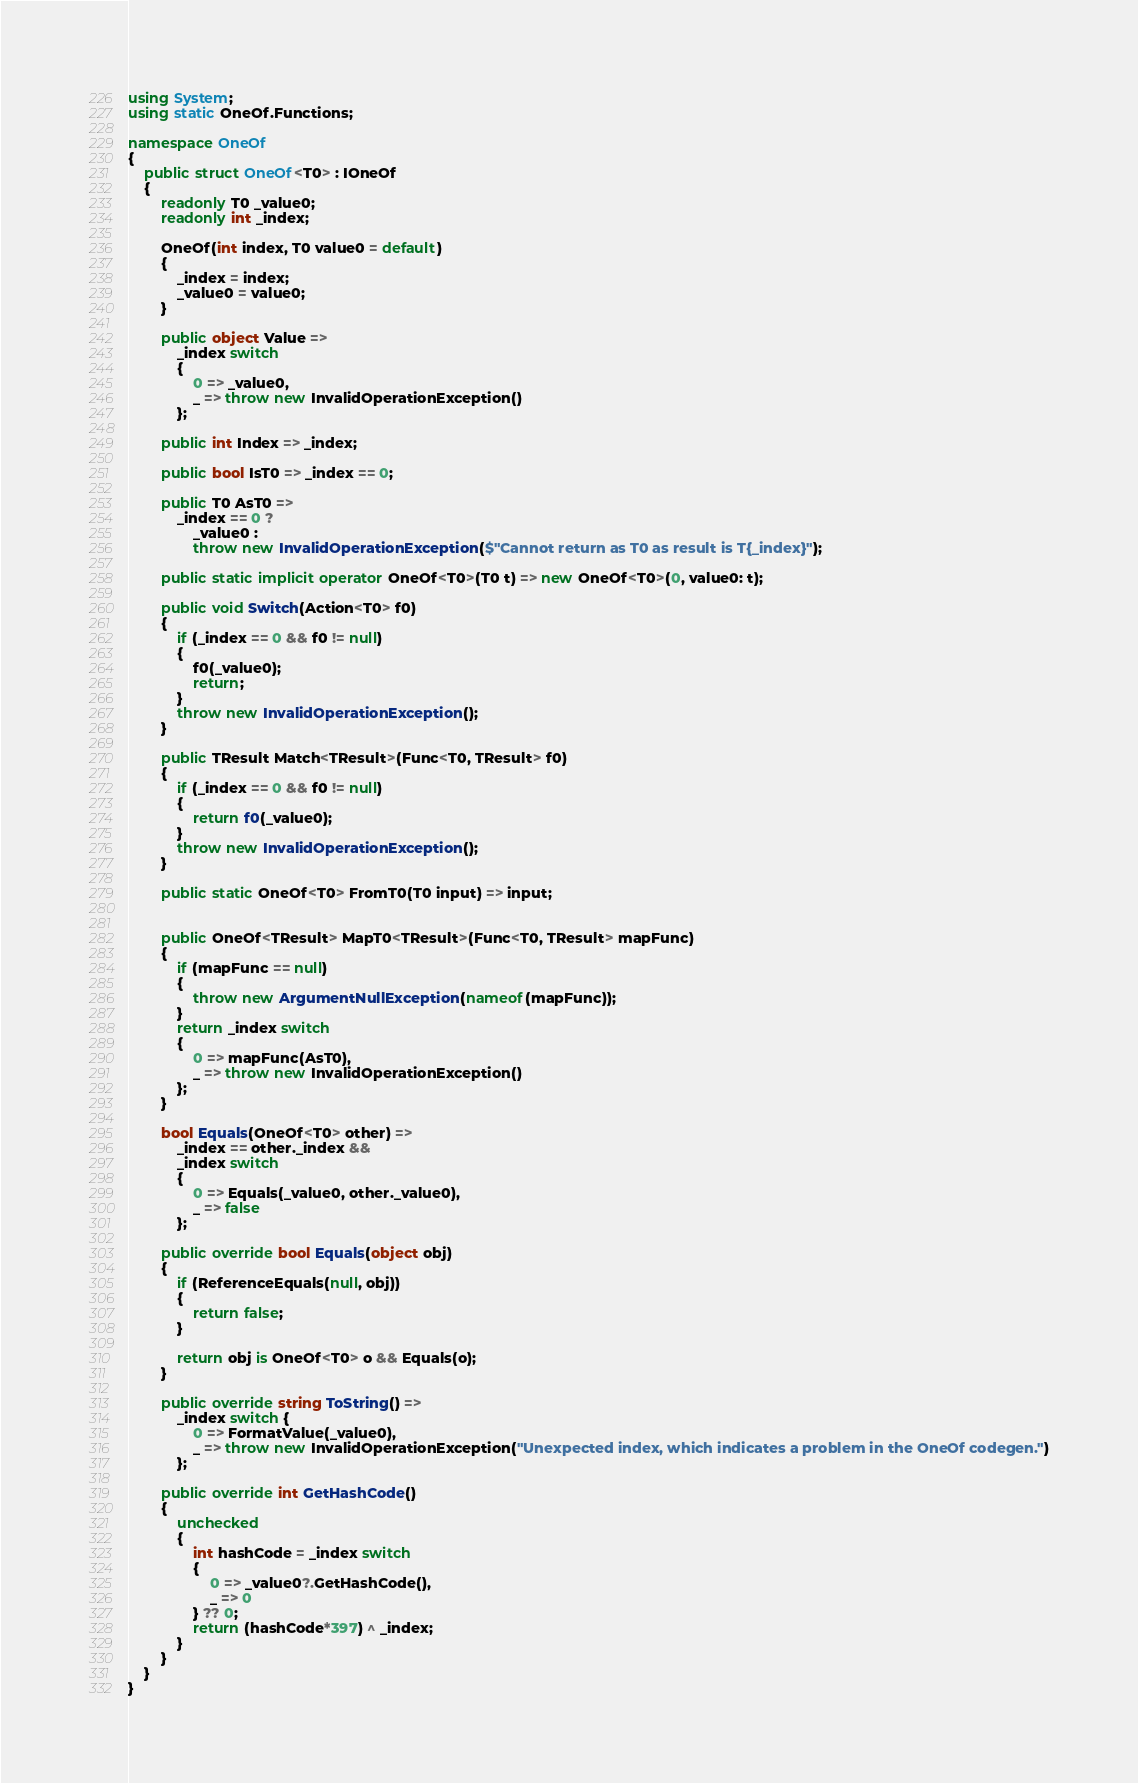Convert code to text. <code><loc_0><loc_0><loc_500><loc_500><_C#_>using System;
using static OneOf.Functions;

namespace OneOf
{
    public struct OneOf<T0> : IOneOf
    {
        readonly T0 _value0;
        readonly int _index;

        OneOf(int index, T0 value0 = default)
        {
            _index = index;
            _value0 = value0;
        }

        public object Value =>
            _index switch
            {
                0 => _value0,
                _ => throw new InvalidOperationException()
            };

        public int Index => _index;

        public bool IsT0 => _index == 0;

        public T0 AsT0 =>
            _index == 0 ?
                _value0 :
                throw new InvalidOperationException($"Cannot return as T0 as result is T{_index}");

        public static implicit operator OneOf<T0>(T0 t) => new OneOf<T0>(0, value0: t);

        public void Switch(Action<T0> f0)
        {
            if (_index == 0 && f0 != null)
            {
                f0(_value0);
                return;
            }
            throw new InvalidOperationException();
        }

        public TResult Match<TResult>(Func<T0, TResult> f0)
        {
            if (_index == 0 && f0 != null)
            {
                return f0(_value0);
            }
            throw new InvalidOperationException();
        }

        public static OneOf<T0> FromT0(T0 input) => input;

        
        public OneOf<TResult> MapT0<TResult>(Func<T0, TResult> mapFunc)
        {
            if (mapFunc == null)
            {
                throw new ArgumentNullException(nameof(mapFunc));
            }
            return _index switch
            {
                0 => mapFunc(AsT0),
                _ => throw new InvalidOperationException()
            };
        }

        bool Equals(OneOf<T0> other) =>
            _index == other._index &&
            _index switch
            {
                0 => Equals(_value0, other._value0),
                _ => false
            };

        public override bool Equals(object obj)
        {
            if (ReferenceEquals(null, obj))
            {
                return false;
            }

            return obj is OneOf<T0> o && Equals(o);
        }

        public override string ToString() =>
            _index switch {
                0 => FormatValue(_value0),
                _ => throw new InvalidOperationException("Unexpected index, which indicates a problem in the OneOf codegen.")
            };

        public override int GetHashCode()
        {
            unchecked
            {
                int hashCode = _index switch
                {
                    0 => _value0?.GetHashCode(),
                    _ => 0
                } ?? 0;
                return (hashCode*397) ^ _index;
            }
        }
    }
}
</code> 